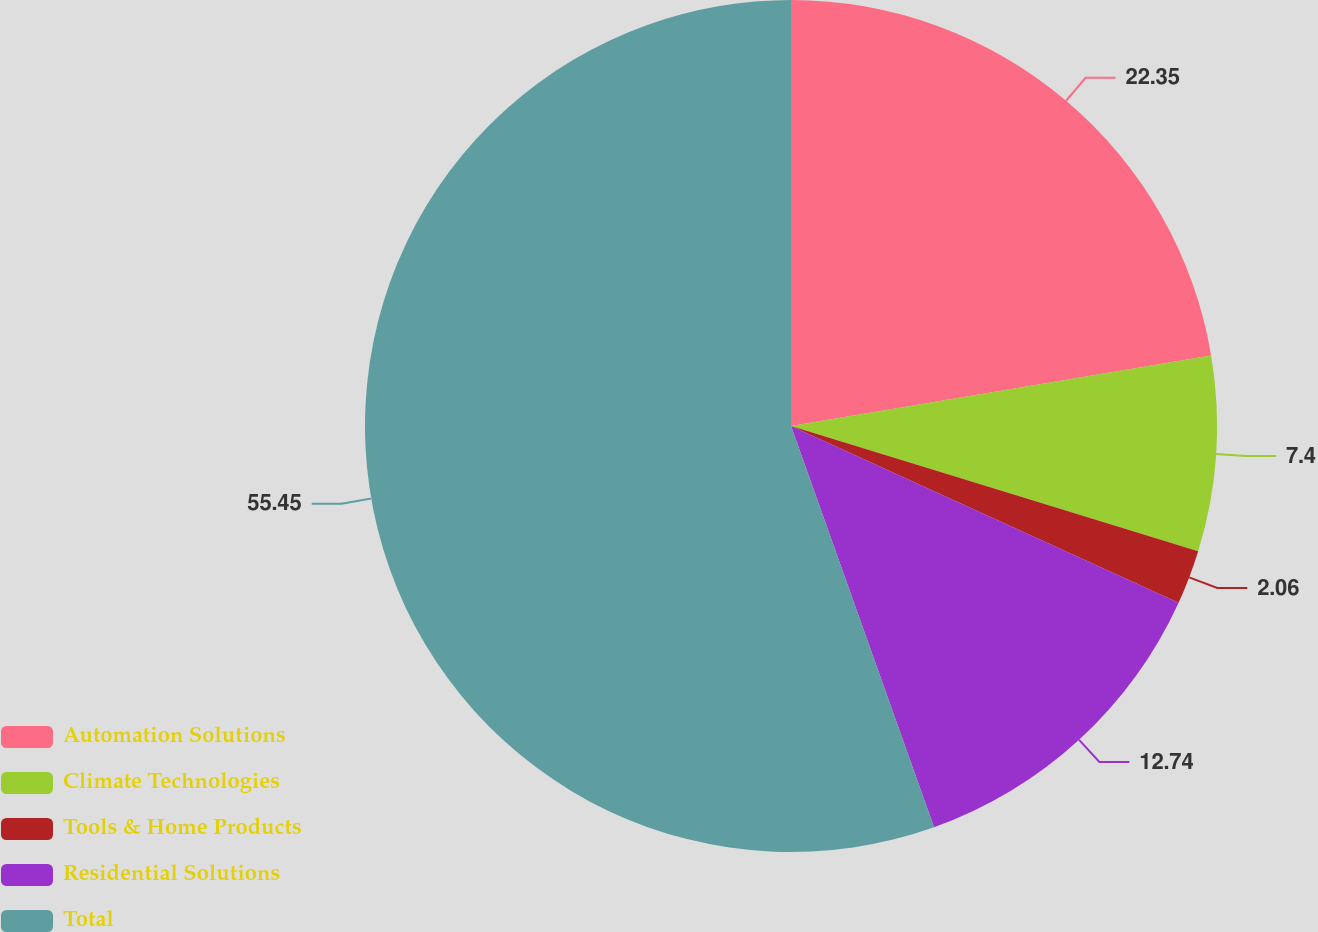Convert chart. <chart><loc_0><loc_0><loc_500><loc_500><pie_chart><fcel>Automation Solutions<fcel>Climate Technologies<fcel>Tools & Home Products<fcel>Residential Solutions<fcel>Total<nl><fcel>22.35%<fcel>7.4%<fcel>2.06%<fcel>12.74%<fcel>55.45%<nl></chart> 